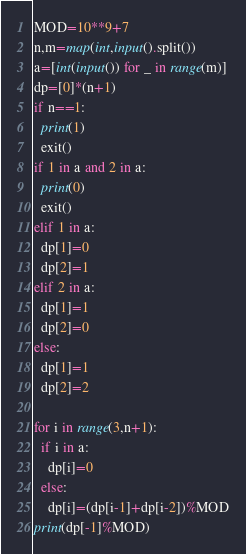<code> <loc_0><loc_0><loc_500><loc_500><_Python_>MOD=10**9+7
n,m=map(int,input().split())
a=[int(input()) for _ in range(m)]
dp=[0]*(n+1)
if n==1:
  print(1)
  exit()
if 1 in a and 2 in a:
  print(0)
  exit()
elif 1 in a:
  dp[1]=0
  dp[2]=1
elif 2 in a:
  dp[1]=1
  dp[2]=0
else:
  dp[1]=1
  dp[2]=2
  
for i in range(3,n+1):
  if i in a:
    dp[i]=0
  else:
    dp[i]=(dp[i-1]+dp[i-2])%MOD
print(dp[-1]%MOD)</code> 